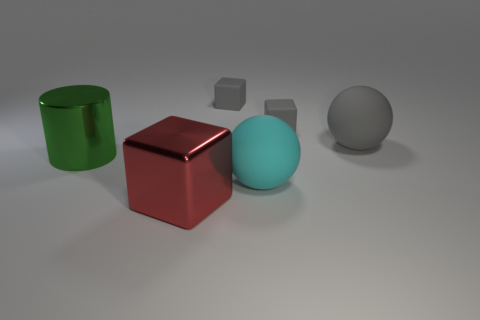How many red spheres are made of the same material as the cyan thing? In the image, there are no red spheres, hence none are made of the same material as the cyan sphere. However, there's a red cube sharing a similar reflective surface characteristic with the cyan sphere, suggesting the possibility of the same or similar material. 